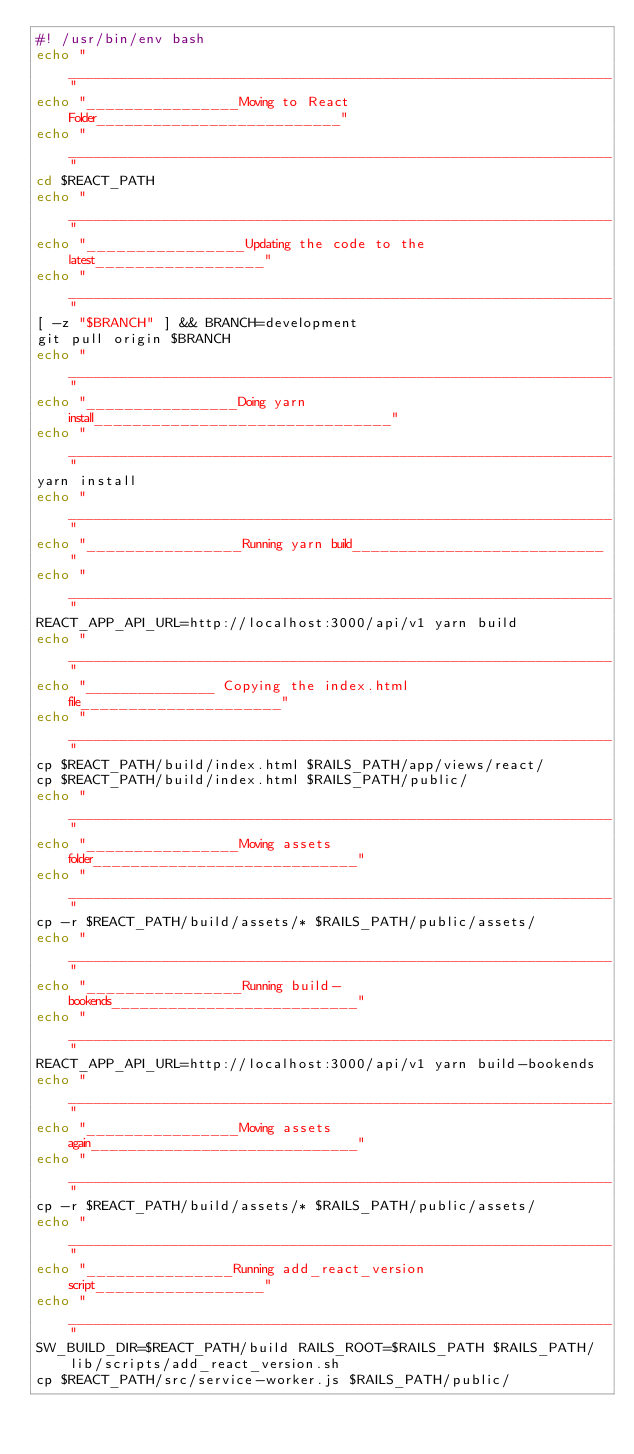Convert code to text. <code><loc_0><loc_0><loc_500><loc_500><_Bash_>#! /usr/bin/env bash
echo "________________________________________________________________"
echo "________________Moving to React Folder__________________________"
echo "________________________________________________________________"
cd $REACT_PATH
echo "________________________________________________________________"
echo "________________Updating the code to the latest_________________"
echo "________________________________________________________________"
[ -z "$BRANCH" ] && BRANCH=development
git pull origin $BRANCH
echo "________________________________________________________________"
echo "________________Doing yarn install_______________________________"
echo "________________________________________________________________"
yarn install
echo "________________________________________________________________"
echo "________________Running yarn build___________________________"
echo "________________________________________________________________"
REACT_APP_API_URL=http://localhost:3000/api/v1 yarn build
echo "________________________________________________________________"
echo "_______________ Copying the index.html file_____________________"
echo "________________________________________________________________"
cp $REACT_PATH/build/index.html $RAILS_PATH/app/views/react/
cp $REACT_PATH/build/index.html $RAILS_PATH/public/
echo "________________________________________________________________"
echo "________________Moving assets folder____________________________"
echo "________________________________________________________________"
cp -r $REACT_PATH/build/assets/* $RAILS_PATH/public/assets/
echo "________________________________________________________________"
echo "________________Running build-bookends__________________________"
echo "________________________________________________________________"
REACT_APP_API_URL=http://localhost:3000/api/v1 yarn build-bookends
echo "________________________________________________________________"
echo "________________Moving assets again_____________________________"
echo "________________________________________________________________"
cp -r $REACT_PATH/build/assets/* $RAILS_PATH/public/assets/
echo "________________________________________________________________"
echo "_______________Running add_react_version script_________________"
echo "________________________________________________________________"
SW_BUILD_DIR=$REACT_PATH/build RAILS_ROOT=$RAILS_PATH $RAILS_PATH/lib/scripts/add_react_version.sh
cp $REACT_PATH/src/service-worker.js $RAILS_PATH/public/
</code> 